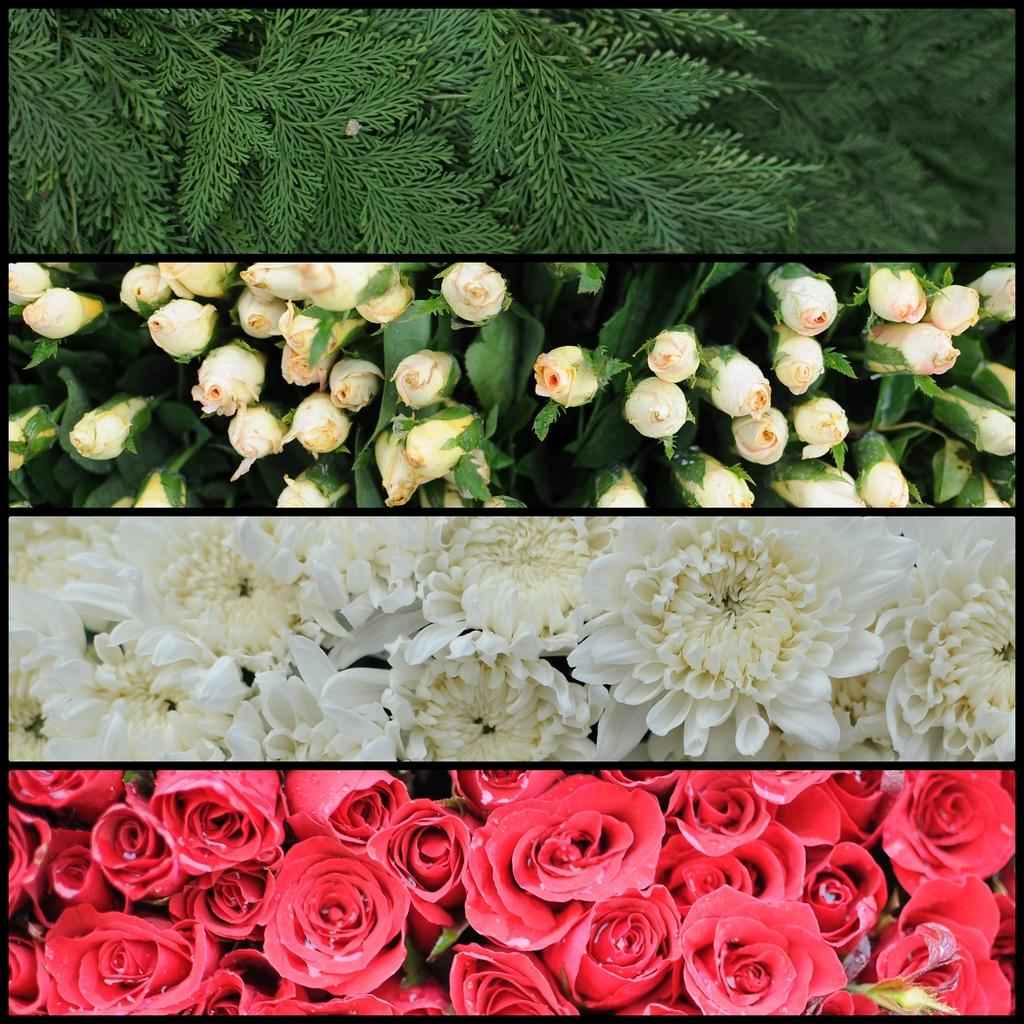What type of artwork is depicted in the image? The image is a collage. What type of flowers can be seen in the image? There are red roses and white flowers in the image. Are there any other types of red flowers in the image besides roses? No, the only red flowers mentioned are roses. What color are the roses that are not red? There are white roses in the image. What other elements are visible in the image besides flowers? Leaves with stems are visible at the top of the image. What brand of toothpaste is advertised in the image? There is no toothpaste present in the image; it is a collage featuring flowers and leaves. What type of fan is visible in the image? There is no fan present in the image; it features flowers and leaves. 